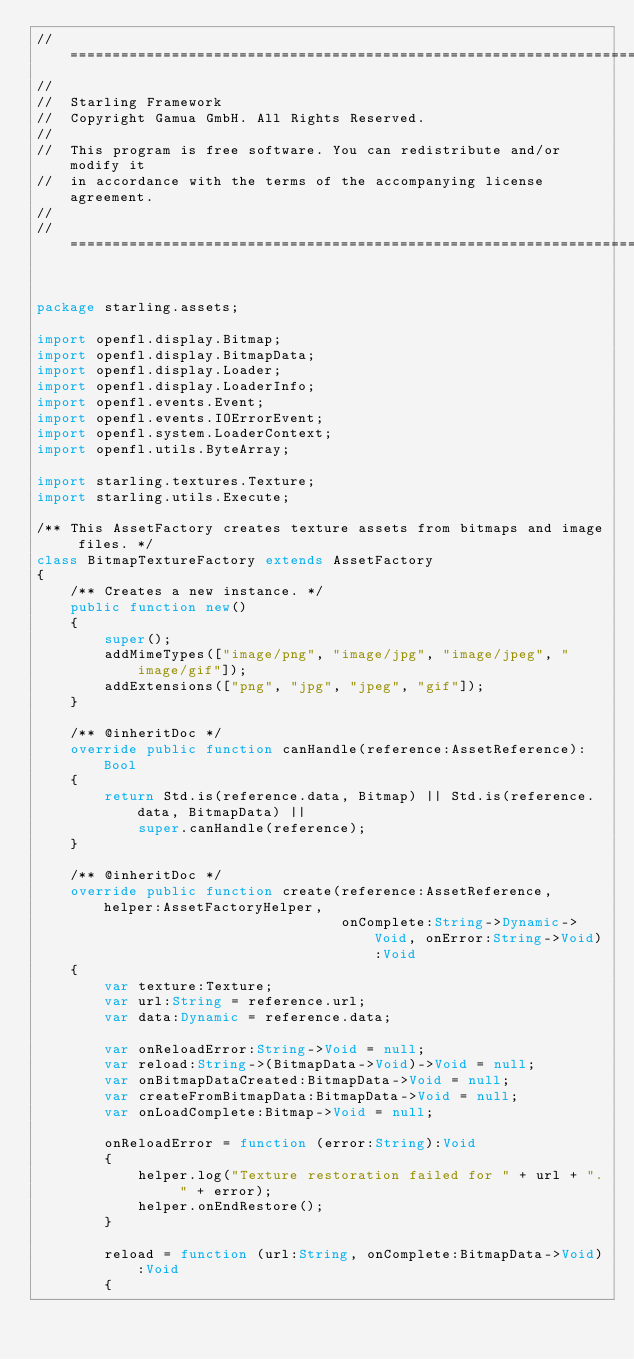<code> <loc_0><loc_0><loc_500><loc_500><_Haxe_>// =================================================================================================
//
//	Starling Framework
//	Copyright Gamua GmbH. All Rights Reserved.
//
//	This program is free software. You can redistribute and/or modify it
//	in accordance with the terms of the accompanying license agreement.
//
// =================================================================================================


package starling.assets;

import openfl.display.Bitmap;
import openfl.display.BitmapData;
import openfl.display.Loader;
import openfl.display.LoaderInfo;
import openfl.events.Event;
import openfl.events.IOErrorEvent;
import openfl.system.LoaderContext;
import openfl.utils.ByteArray;

import starling.textures.Texture;
import starling.utils.Execute;

/** This AssetFactory creates texture assets from bitmaps and image files. */
class BitmapTextureFactory extends AssetFactory
{
    /** Creates a new instance. */
    public function new()
    {
        super();
        addMimeTypes(["image/png", "image/jpg", "image/jpeg", "image/gif"]);
        addExtensions(["png", "jpg", "jpeg", "gif"]);
    }

    /** @inheritDoc */
    override public function canHandle(reference:AssetReference):Bool
    {
        return Std.is(reference.data, Bitmap) || Std.is(reference.data, BitmapData) ||
            super.canHandle(reference);
    }

    /** @inheritDoc */
    override public function create(reference:AssetReference, helper:AssetFactoryHelper,
                                    onComplete:String->Dynamic->Void, onError:String->Void):Void
    {
        var texture:Texture;
        var url:String = reference.url;
        var data:Dynamic = reference.data;
        
        var onReloadError:String->Void = null;
        var reload:String->(BitmapData->Void)->Void = null;
        var onBitmapDataCreated:BitmapData->Void = null;
        var createFromBitmapData:BitmapData->Void = null;
        var onLoadComplete:Bitmap->Void = null;
        
        onReloadError = function (error:String):Void
        {
            helper.log("Texture restoration failed for " + url + ". " + error);
            helper.onEndRestore();
        }
        
        reload = function (url:String, onComplete:BitmapData->Void):Void
        {</code> 